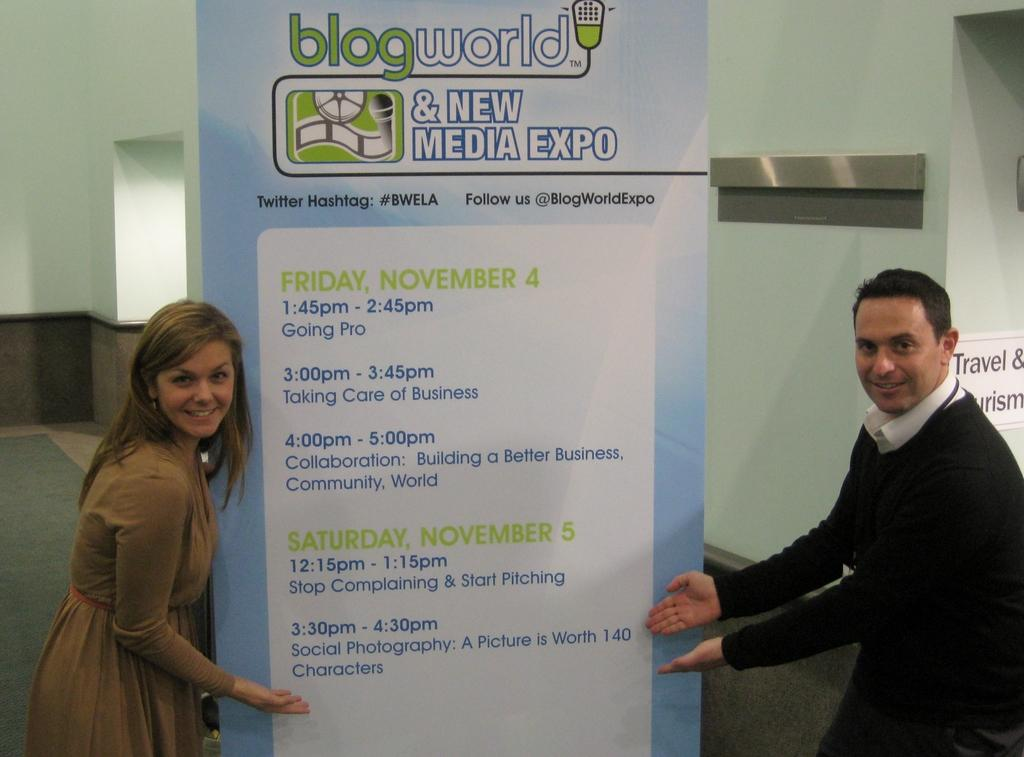How many people are in the image? There are two people in the image, a man and a woman. What are the man and woman doing in the image? The man and woman are standing. What can be seen on the wall in the background of the image? There is a poster on the wall in the background of the image. What is the background of the image? There is a wall in the background of the image. What type of book is the man reading in the image? There is no book present in the image; the man and woman are standing and not engaged in any reading activity. 